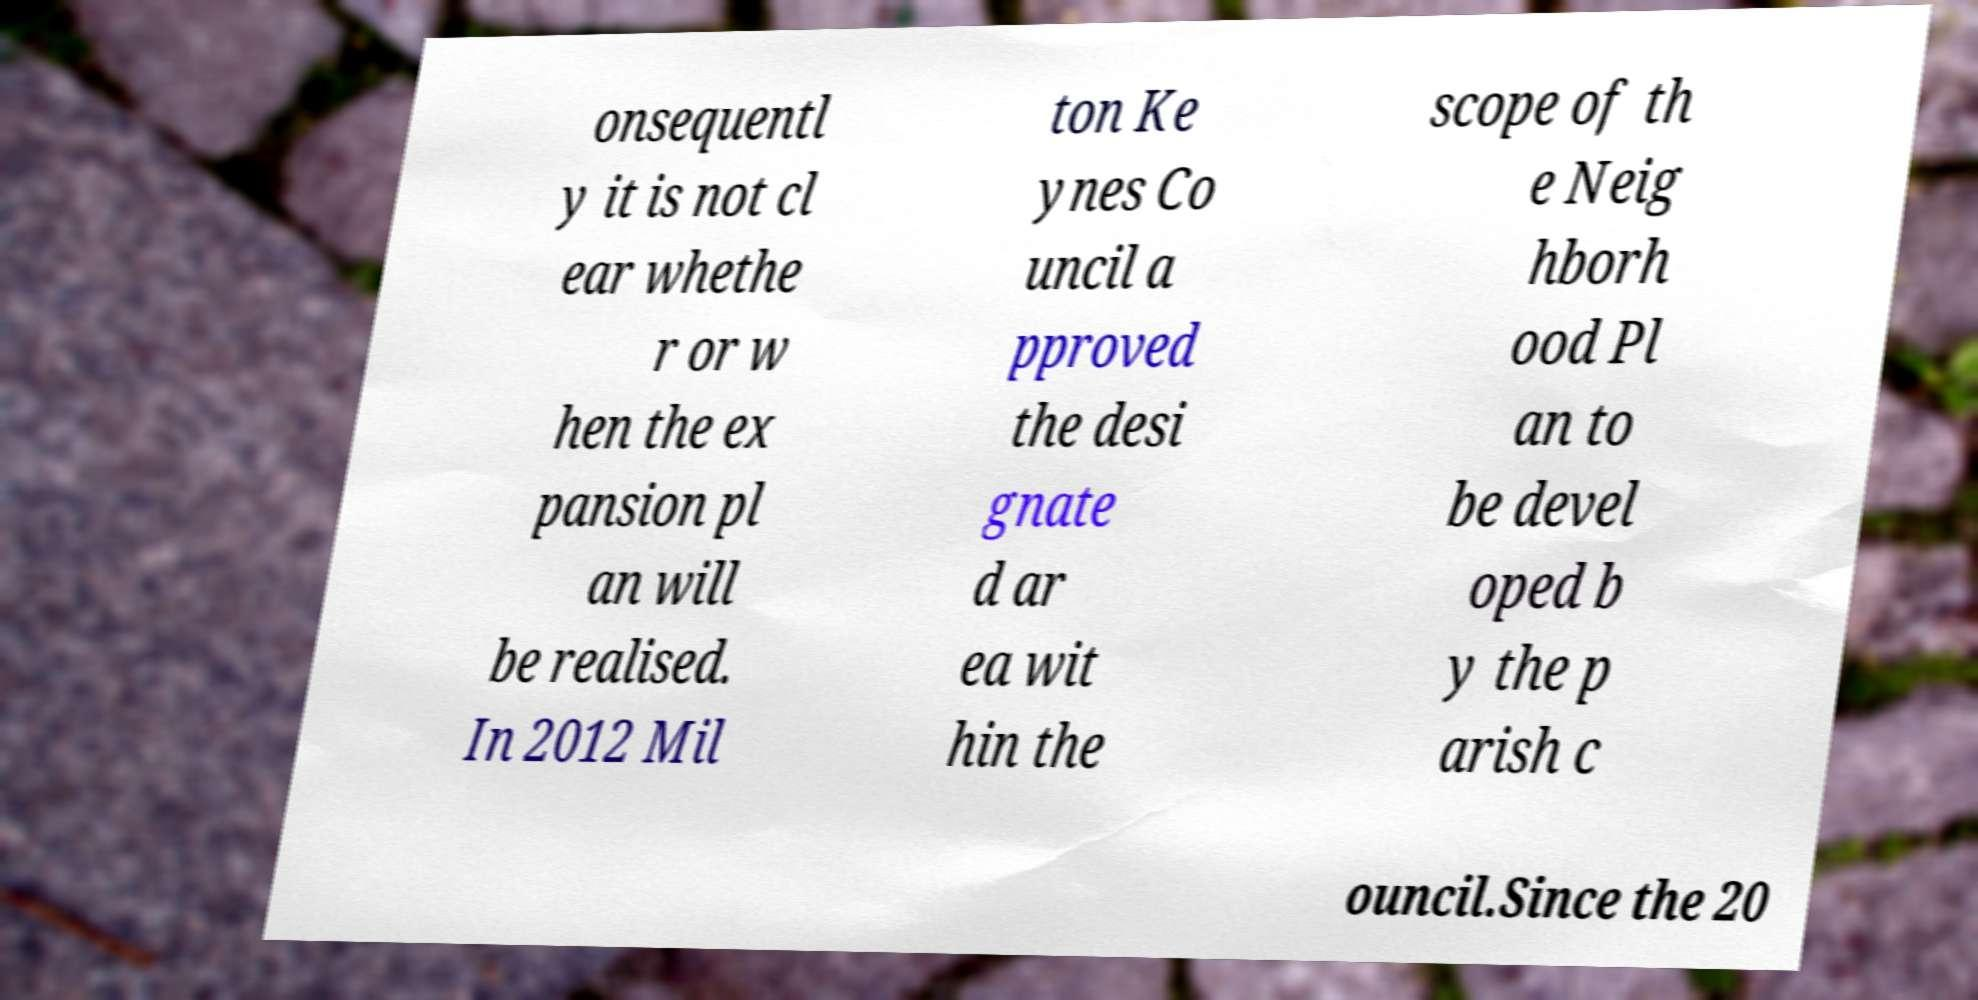For documentation purposes, I need the text within this image transcribed. Could you provide that? onsequentl y it is not cl ear whethe r or w hen the ex pansion pl an will be realised. In 2012 Mil ton Ke ynes Co uncil a pproved the desi gnate d ar ea wit hin the scope of th e Neig hborh ood Pl an to be devel oped b y the p arish c ouncil.Since the 20 